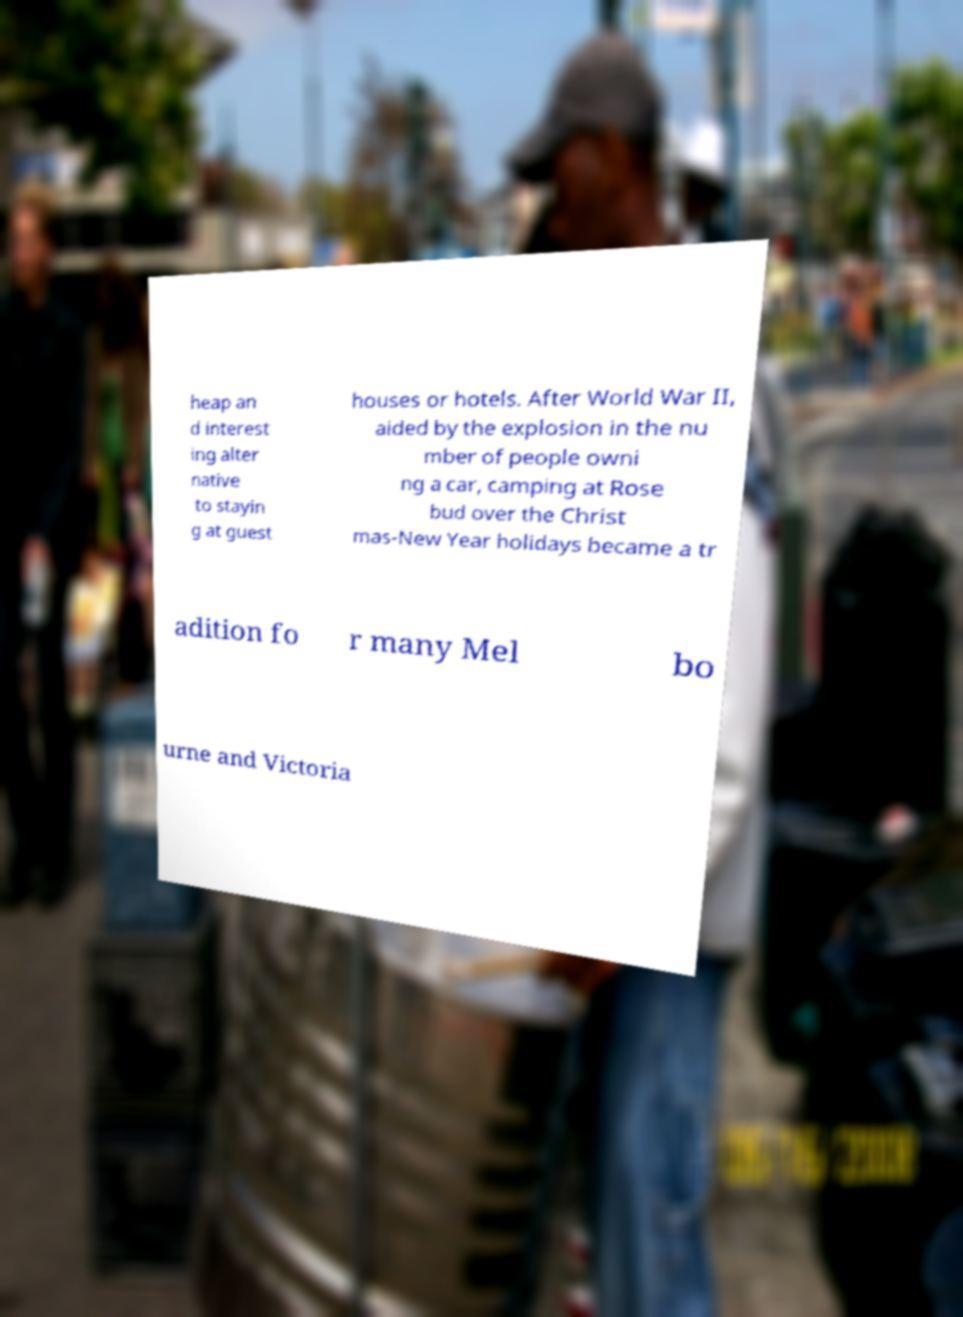Could you extract and type out the text from this image? heap an d interest ing alter native to stayin g at guest houses or hotels. After World War II, aided by the explosion in the nu mber of people owni ng a car, camping at Rose bud over the Christ mas-New Year holidays became a tr adition fo r many Mel bo urne and Victoria 